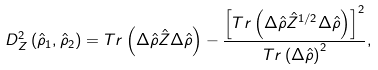Convert formula to latex. <formula><loc_0><loc_0><loc_500><loc_500>D _ { Z } ^ { 2 } \left ( \hat { \rho } _ { 1 } , \hat { \rho } _ { 2 } \right ) = T r \left ( \Delta \hat { \rho } \hat { Z } \Delta \hat { \rho } \right ) - \frac { \left [ T r \left ( \Delta \hat { \rho } \hat { Z } ^ { 1 / 2 } \Delta \hat { \rho } \right ) \right ] ^ { 2 } } { T r \left ( \Delta \hat { \rho } \right ) ^ { 2 } } ,</formula> 